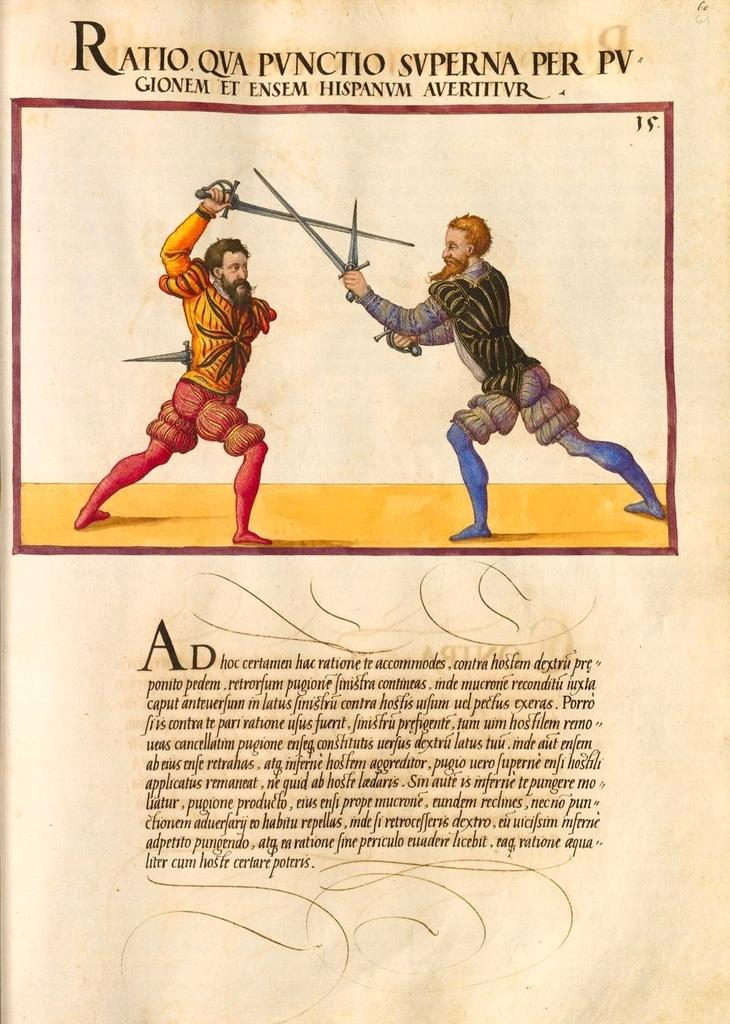What is the main subject of the image? There is a depiction in the image. Can you describe any labels or identifiers associated with the depiction? Yes, there are names above the depiction. Is there any additional information provided in the image? Yes, there is text under the depiction. What type of rifle is being used in the image? There is no rifle present in the image; it features a depiction with names above it and text below it. What type of suit is the person wearing in the image? There is no person wearing a suit in the image; it features a depiction with names above it and text below it. 